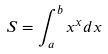Convert formula to latex. <formula><loc_0><loc_0><loc_500><loc_500>S = \int _ { a } ^ { b } x ^ { x } d x</formula> 